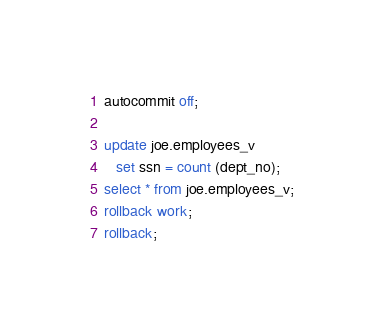<code> <loc_0><loc_0><loc_500><loc_500><_SQL_>autocommit off;

update joe.employees_v
   set ssn = count (dept_no);
select * from joe.employees_v;
rollback work;
rollback;
</code> 